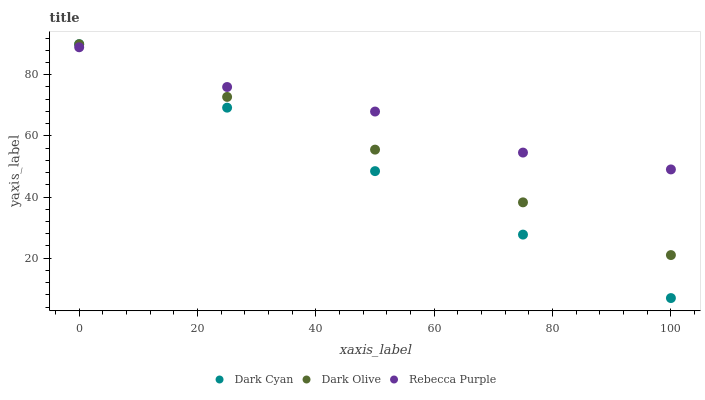Does Dark Cyan have the minimum area under the curve?
Answer yes or no. Yes. Does Rebecca Purple have the maximum area under the curve?
Answer yes or no. Yes. Does Dark Olive have the minimum area under the curve?
Answer yes or no. No. Does Dark Olive have the maximum area under the curve?
Answer yes or no. No. Is Dark Cyan the smoothest?
Answer yes or no. Yes. Is Rebecca Purple the roughest?
Answer yes or no. Yes. Is Dark Olive the smoothest?
Answer yes or no. No. Is Dark Olive the roughest?
Answer yes or no. No. Does Dark Cyan have the lowest value?
Answer yes or no. Yes. Does Dark Olive have the lowest value?
Answer yes or no. No. Does Dark Olive have the highest value?
Answer yes or no. Yes. Does Rebecca Purple have the highest value?
Answer yes or no. No. Does Dark Cyan intersect Rebecca Purple?
Answer yes or no. Yes. Is Dark Cyan less than Rebecca Purple?
Answer yes or no. No. Is Dark Cyan greater than Rebecca Purple?
Answer yes or no. No. 